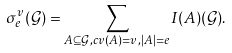Convert formula to latex. <formula><loc_0><loc_0><loc_500><loc_500>\sigma _ { e } ^ { v } ( { \mathcal { G } } ) = \sum _ { A \subseteq { \mathcal { G } } , c v ( A ) = v , | A | = e } I ( A ) ( { \mathcal { G } } ) .</formula> 